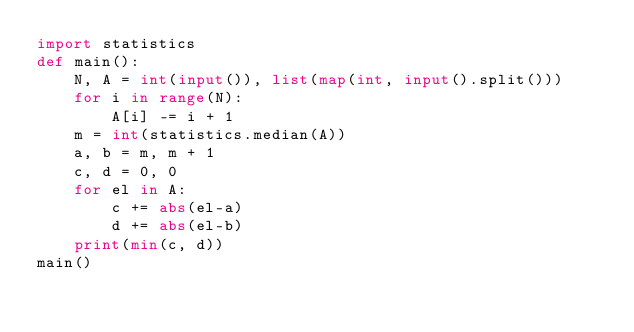<code> <loc_0><loc_0><loc_500><loc_500><_Python_>import statistics
def main():
    N, A = int(input()), list(map(int, input().split()))
    for i in range(N):
        A[i] -= i + 1
    m = int(statistics.median(A))
    a, b = m, m + 1
    c, d = 0, 0
    for el in A:
        c += abs(el-a)
        d += abs(el-b)
    print(min(c, d))
main()</code> 